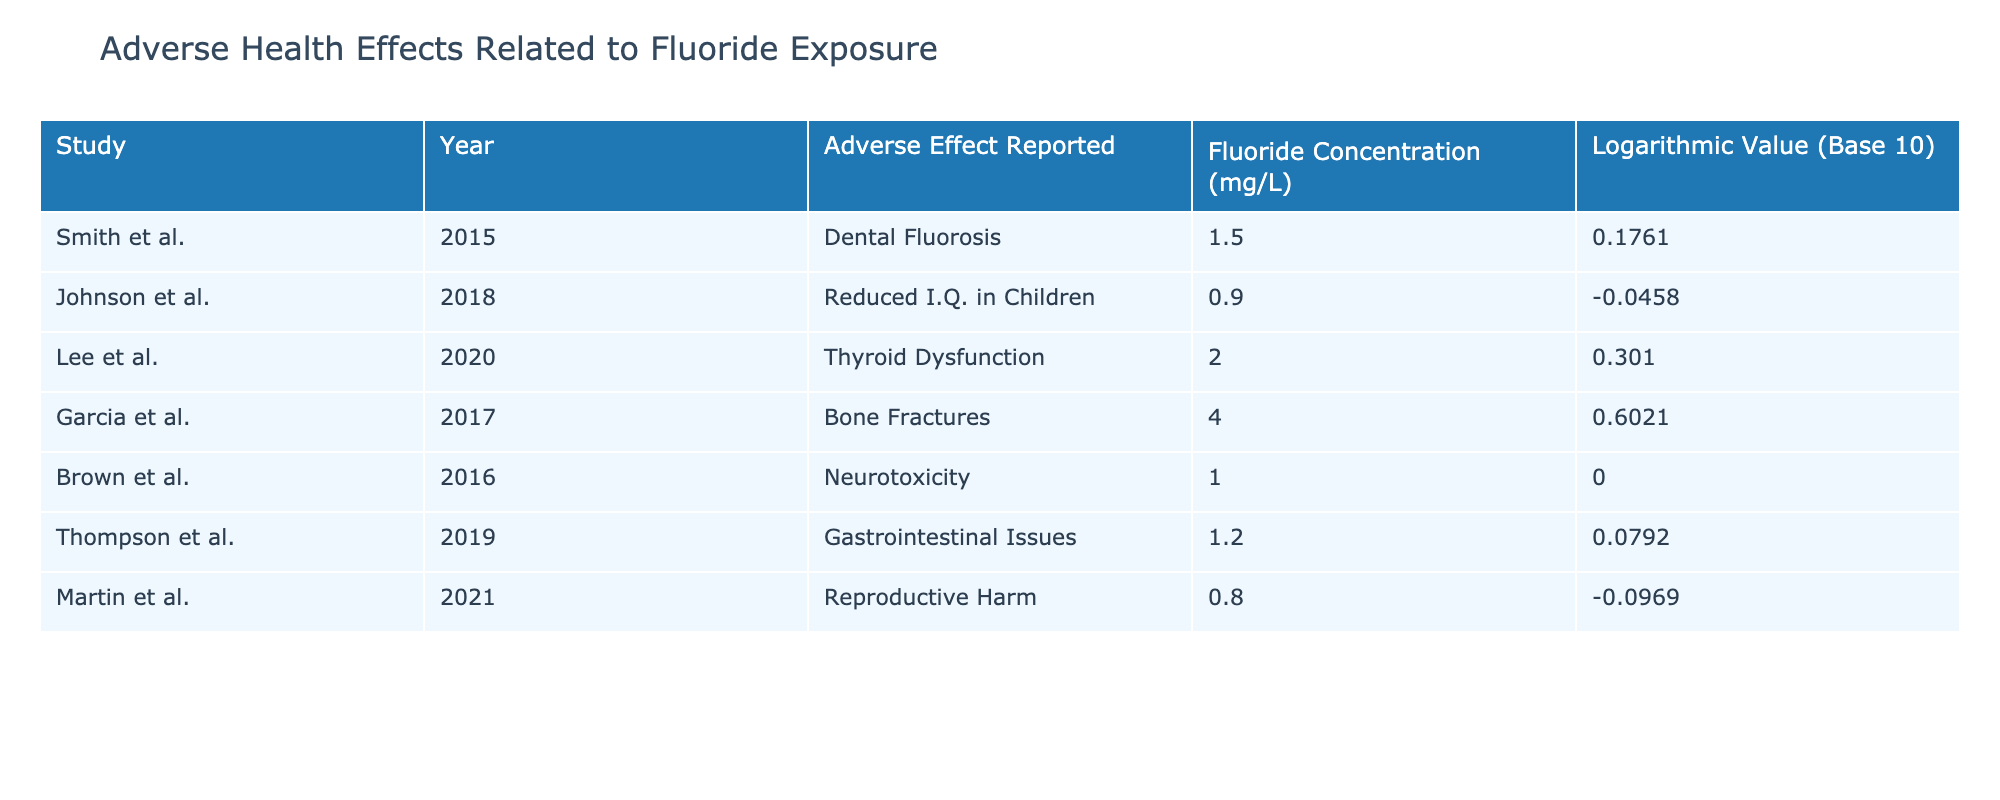What adverse effect was reported by Smith et al. in 2015? According to the table, Smith et al. (2015) reported Dental Fluorosis as the adverse effect.
Answer: Dental Fluorosis Which study reported a fluoride concentration of 2.0 mg/L? The table indicates that Lee et al. (2020) reported a fluoride concentration of 2.0 mg/L.
Answer: Lee et al. (2020) What is the log value for the study that reported Gastrointestinal Issues? From the table, Thompson et al. (2019) reported Gastrointestinal Issues and had a logarithmic value of 0.0792.
Answer: 0.0792 Which adverse effect was reported by Martin et al. and what was the fluoride concentration? Martin et al. reported Reproductive Harm at a fluoride concentration of 0.8 mg/L.
Answer: Reproductive Harm; 0.8 mg/L Is there any study in the table that links fluoride exposure to reduced I.Q. in children? Yes, Johnson et al. (2018) reported Reduced I.Q. in Children related to fluoride exposure.
Answer: Yes What is the average fluoride concentration across all studies listed in the table? To find the average, sum the fluoride concentrations: (1.5 + 0.9 + 2.0 + 4.0 + 1.0 + 1.2 + 0.8) = 11.4, then divide by 7 (the number of studies) to get 11.4 / 7 = 1.62857. Thus, the average fluoride concentration is approximately 1.63 mg/L.
Answer: 1.63 mg/L How many studies reported fluoride concentrations below 1.0 mg/L? Based on the table, only 2 studies (Johnson et al. and Martin et al.) reported fluoride concentrations below 1.0 mg/L.
Answer: 2 studies Which adverse effect has the highest reported fluoride concentration? The table reveals that Garcia et al. (2017) reported Bone Fractures at the highest fluoride concentration of 4.0 mg/L.
Answer: Bone Fractures Was Neurotoxicity reported in a study with a logarithmic value greater than 0? No, Brown et al. (2016) reported Neurotoxicity with a logarithmic value of 0.0000, which is not greater than 0.
Answer: No 